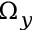Convert formula to latex. <formula><loc_0><loc_0><loc_500><loc_500>\Omega _ { y }</formula> 